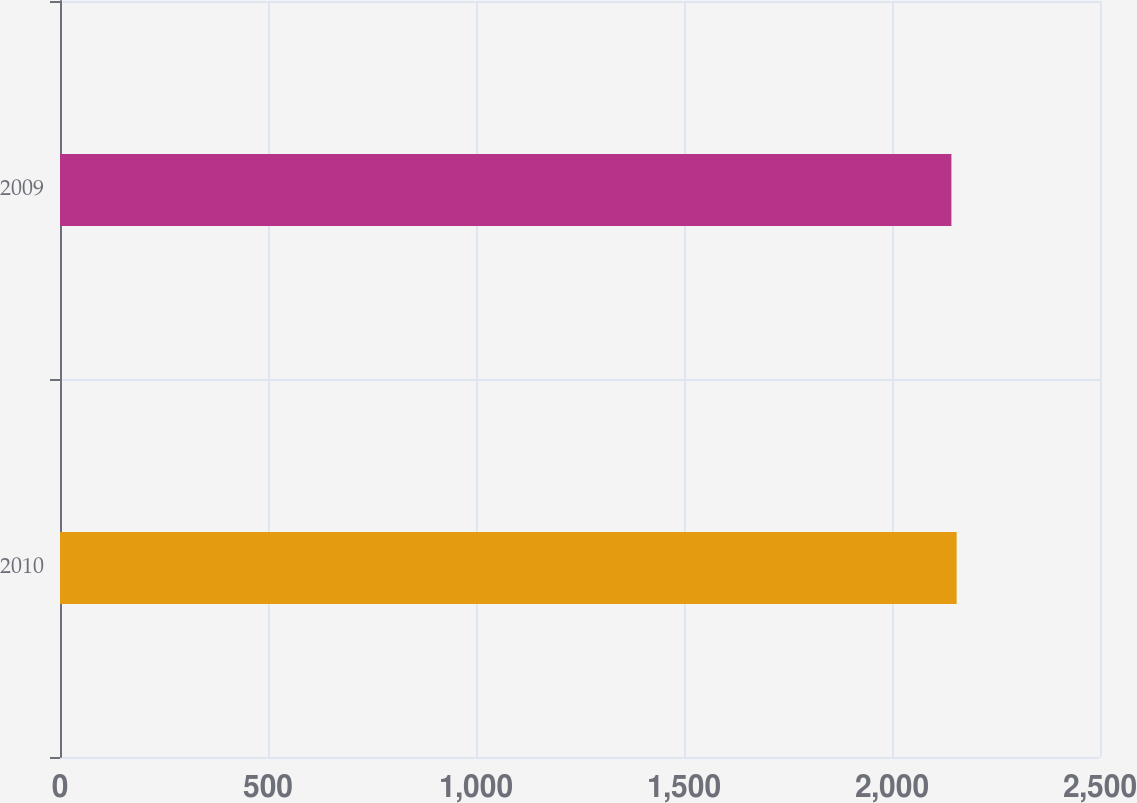Convert chart. <chart><loc_0><loc_0><loc_500><loc_500><bar_chart><fcel>2010<fcel>2009<nl><fcel>2155.4<fcel>2142.8<nl></chart> 